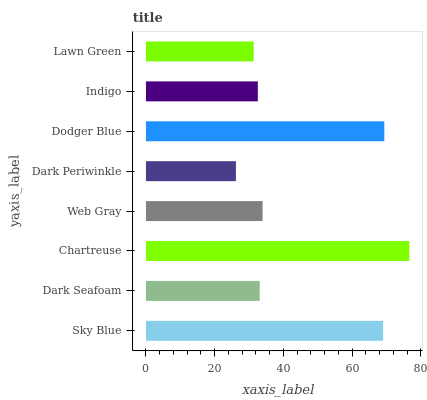Is Dark Periwinkle the minimum?
Answer yes or no. Yes. Is Chartreuse the maximum?
Answer yes or no. Yes. Is Dark Seafoam the minimum?
Answer yes or no. No. Is Dark Seafoam the maximum?
Answer yes or no. No. Is Sky Blue greater than Dark Seafoam?
Answer yes or no. Yes. Is Dark Seafoam less than Sky Blue?
Answer yes or no. Yes. Is Dark Seafoam greater than Sky Blue?
Answer yes or no. No. Is Sky Blue less than Dark Seafoam?
Answer yes or no. No. Is Web Gray the high median?
Answer yes or no. Yes. Is Dark Seafoam the low median?
Answer yes or no. Yes. Is Dodger Blue the high median?
Answer yes or no. No. Is Lawn Green the low median?
Answer yes or no. No. 